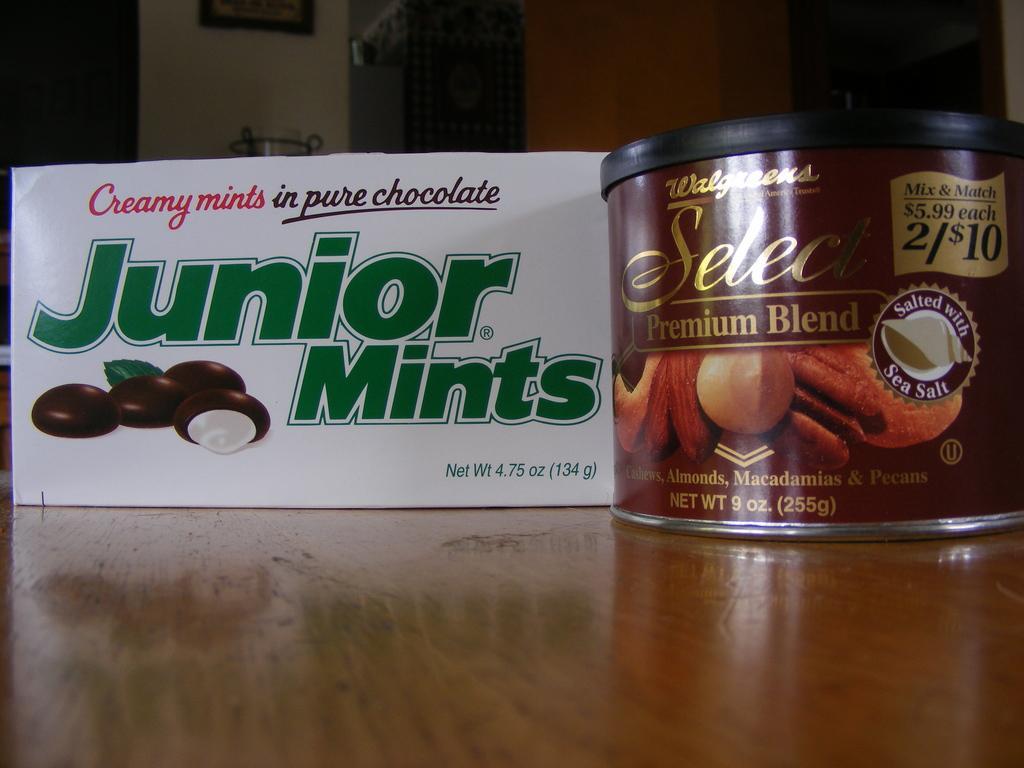Can you describe this image briefly? In this image I can see the box and the board on the brown color surface. In the background I can see the frame to the wall. 